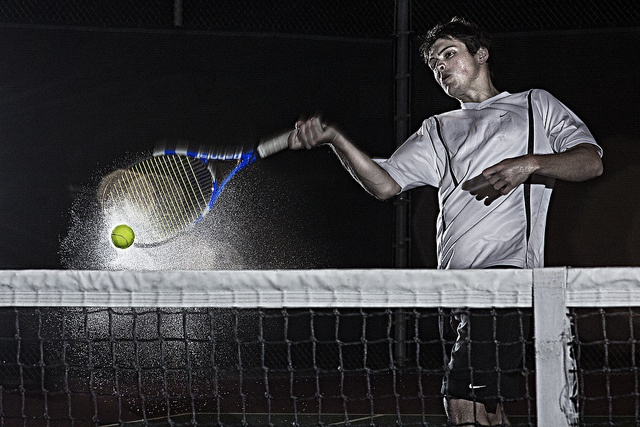Describe the objects in this image and their specific colors. I can see people in black, darkgray, gray, and lightgray tones, tennis racket in black, gray, darkgray, and lightgray tones, and sports ball in black, olive, darkgreen, and khaki tones in this image. 